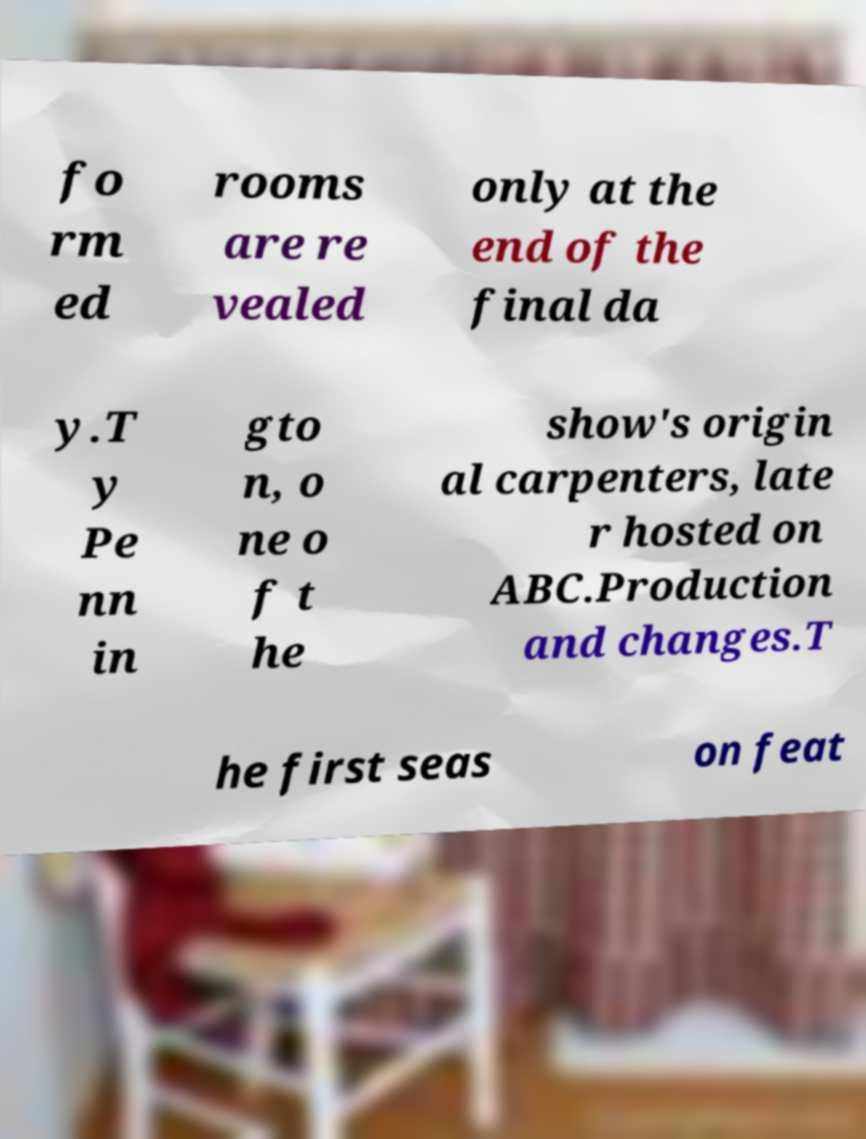For documentation purposes, I need the text within this image transcribed. Could you provide that? fo rm ed rooms are re vealed only at the end of the final da y.T y Pe nn in gto n, o ne o f t he show's origin al carpenters, late r hosted on ABC.Production and changes.T he first seas on feat 